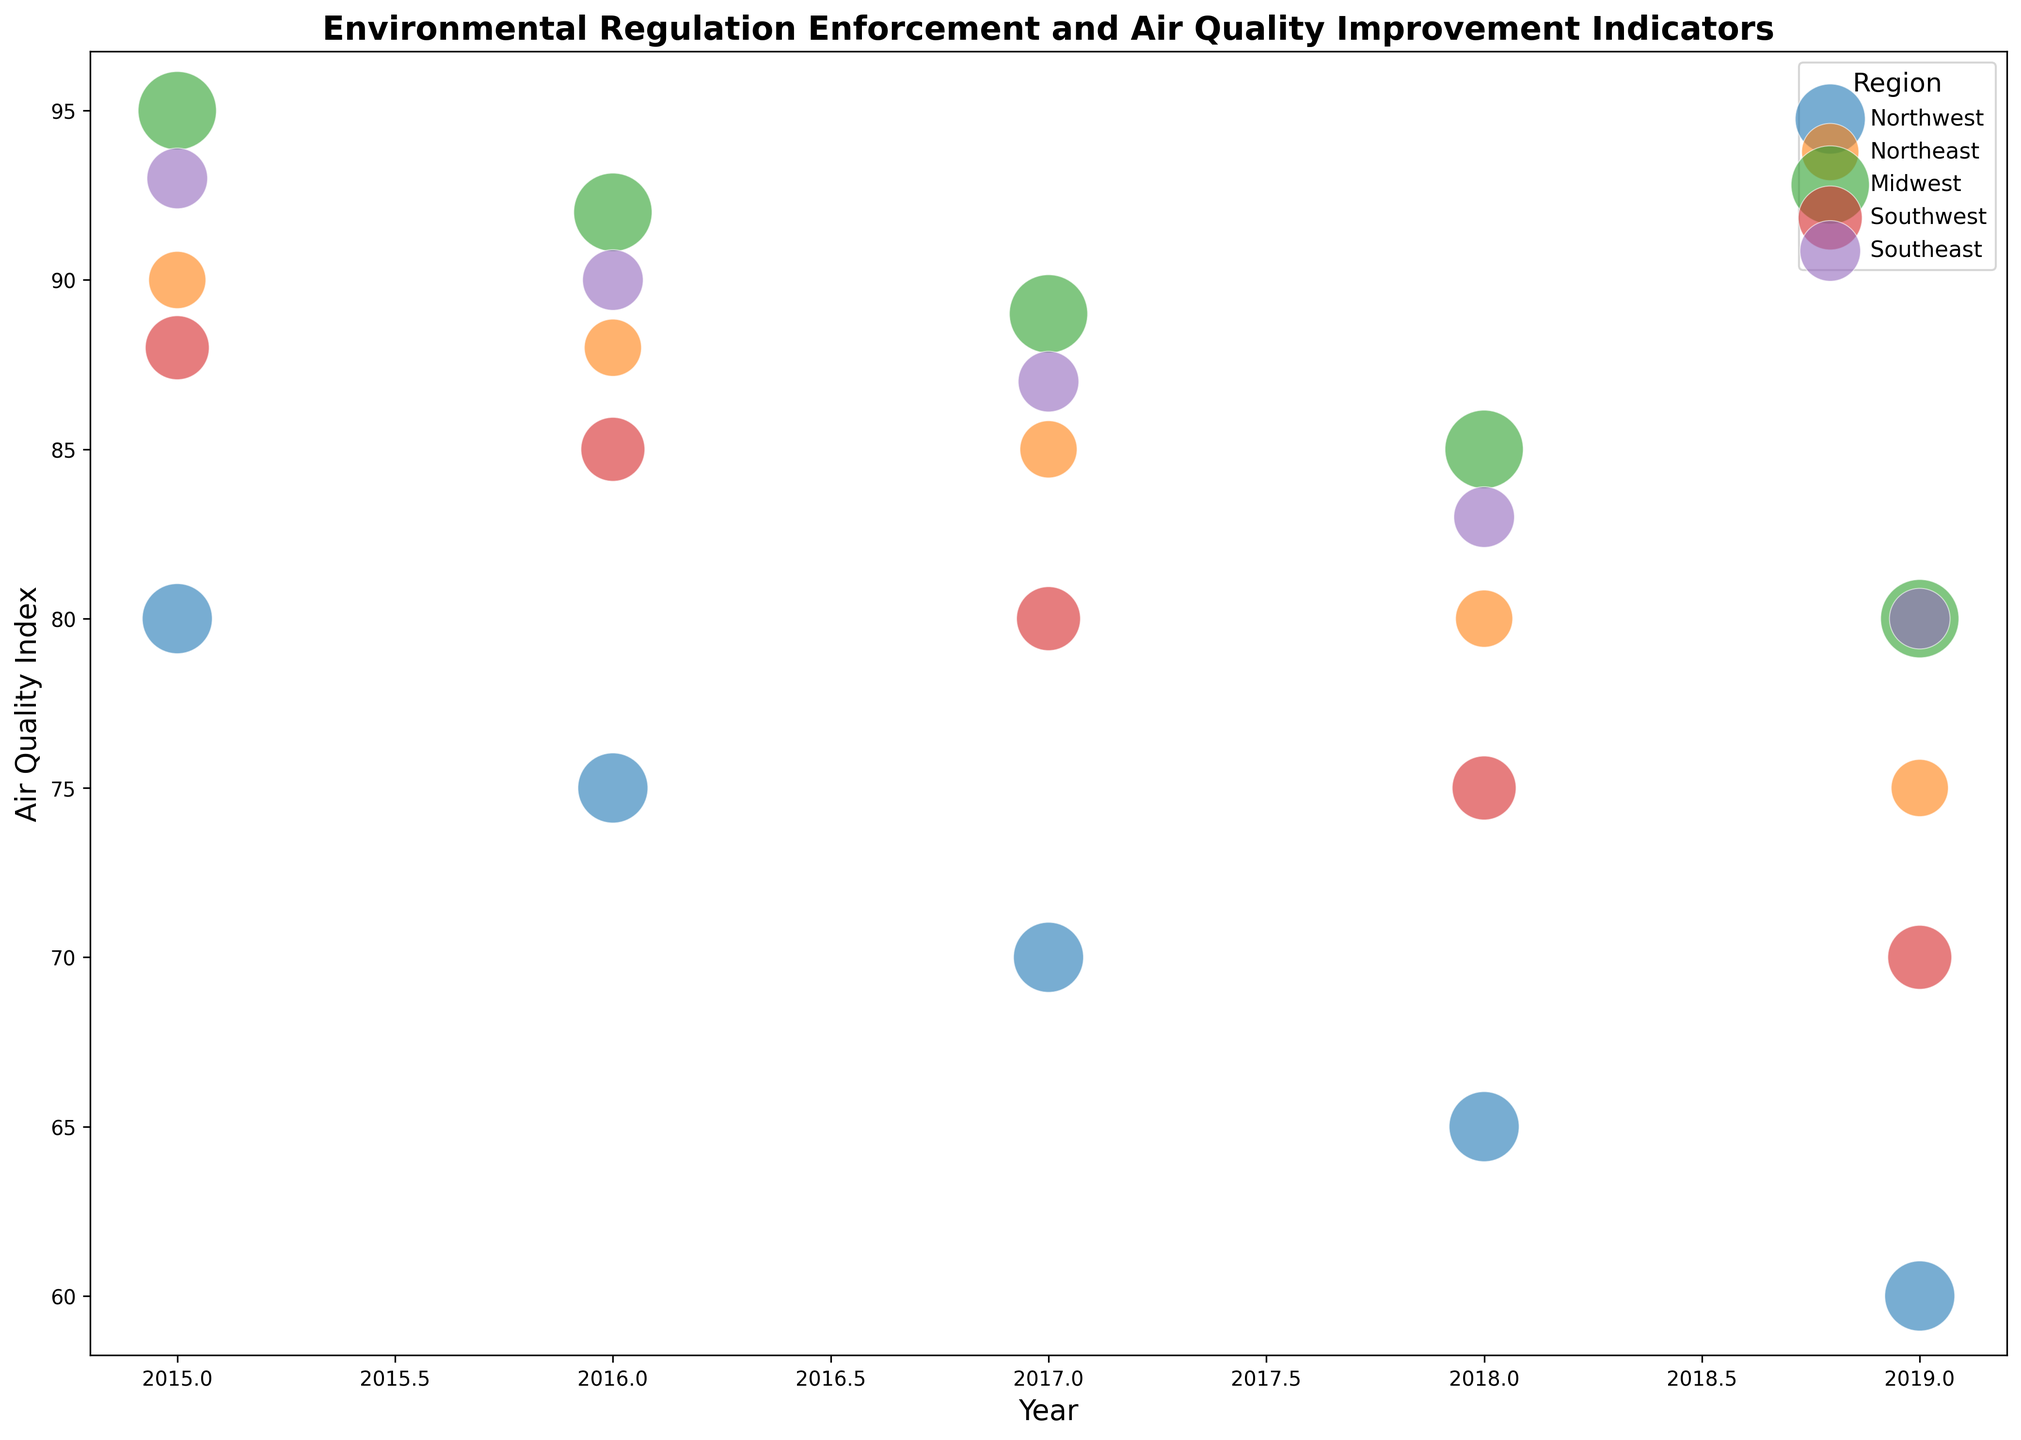Which region saw the most significant improvement in Air Quality Index between 2015 and 2019? Observing the change in Air Quality Index for each region between 2015 and 2019, the Northwest improved from 80 to 60, showing a decrease of 20. The Southwest improved from 88 to 70, showing a decrease of 18. The Southeast improved from 93 to 80, showing a decrease of 13. The Midwest improved from 95 to 80, showing a decrease of 15. The Northeast improved from 90 to 75, showing a decrease of 15. Thus, the Northwest saw the most significant improvement with a 20-point decrease.
Answer: Northwest Which region had the highest Air Quality Index in 2015, and what was its population exposure? Checking the Air Quality Index for all regions in 2015: Northwest had 80, Northeast had 90, Midwest had 95, Southwest had 88, Southeast had 93. The Midwest had the highest index at 95. Its population exposure was 1,500,000 (1.5 million).
Answer: Midwest, 1.5 million In which year did the Southeast region enforce more regulations than the Northeast, and what were the Air Quality Index values for both regions in that year? Looking at the year-wise enforcement data: In 2018, the Southeast enforced 9 regulations while the Northeast enforced 8. The Southeast's Air Quality Index was 83, and the Northeast's Air Quality Index was 80.
Answer: 2018, Southeast: 83, Northeast: 80 Which region had the largest bubble in 2019, and what does it represent? The bubbles represent population exposure, with larger bubbles indicating higher populations. In 2019, the Midwest has the largest bubble, indicating it had the highest population exposure of 1,500,000 people.
Answer: Midwest, population exposure By which year did the Midwest improve its Air Quality Index to 80? Observing the trend of the Air Quality Index in the Midwest: starting from 95 in 2015, it decreases yearly. The Midwest reaches an index of 80 by 2019.
Answer: 2019 How many regulations did the Southwest enforce by 2018, and what was its Air Quality Index that year? Checking the enforcement and Air Quality Index data for the Southwest: By 2018, they enforced 10 regulations, with an Air Quality Index of 75.
Answer: 10, 75 Compare the Air Quality Index improvements from 2015 to 2017 between the Northeast and Southeast regions. Which improved more, and by how much? The Northeast improved from 90 in 2015 to 85 in 2017, which is an improvement of 5 points. The Southeast improved from 93 in 2015 to 87 in 2017, which is an improvement of 6 points. The Southeast improved more by 1 point.
Answer: Southeast, by 1 point Which region shows a continuous yearly decrease in CO2 Emissions from 2015 to 2019, and what is the total decrease over these years? The emissions data for each region from 2015 to 2019: Northwest decreased from 150 to 125 (total decrease of 25), Northeast decreased from 200 to 180 (total decrease of 20), Midwest decreased from 210 to 190 (total decrease of 20), Southwest decreased from 160 to 140 (total decrease of 20), Southeast decreased from 170 to 150 (total decrease of 20). All regions show continuous yearly decreases, but focus on Northwest for uniqueness.
Answer: Northwest, 25 